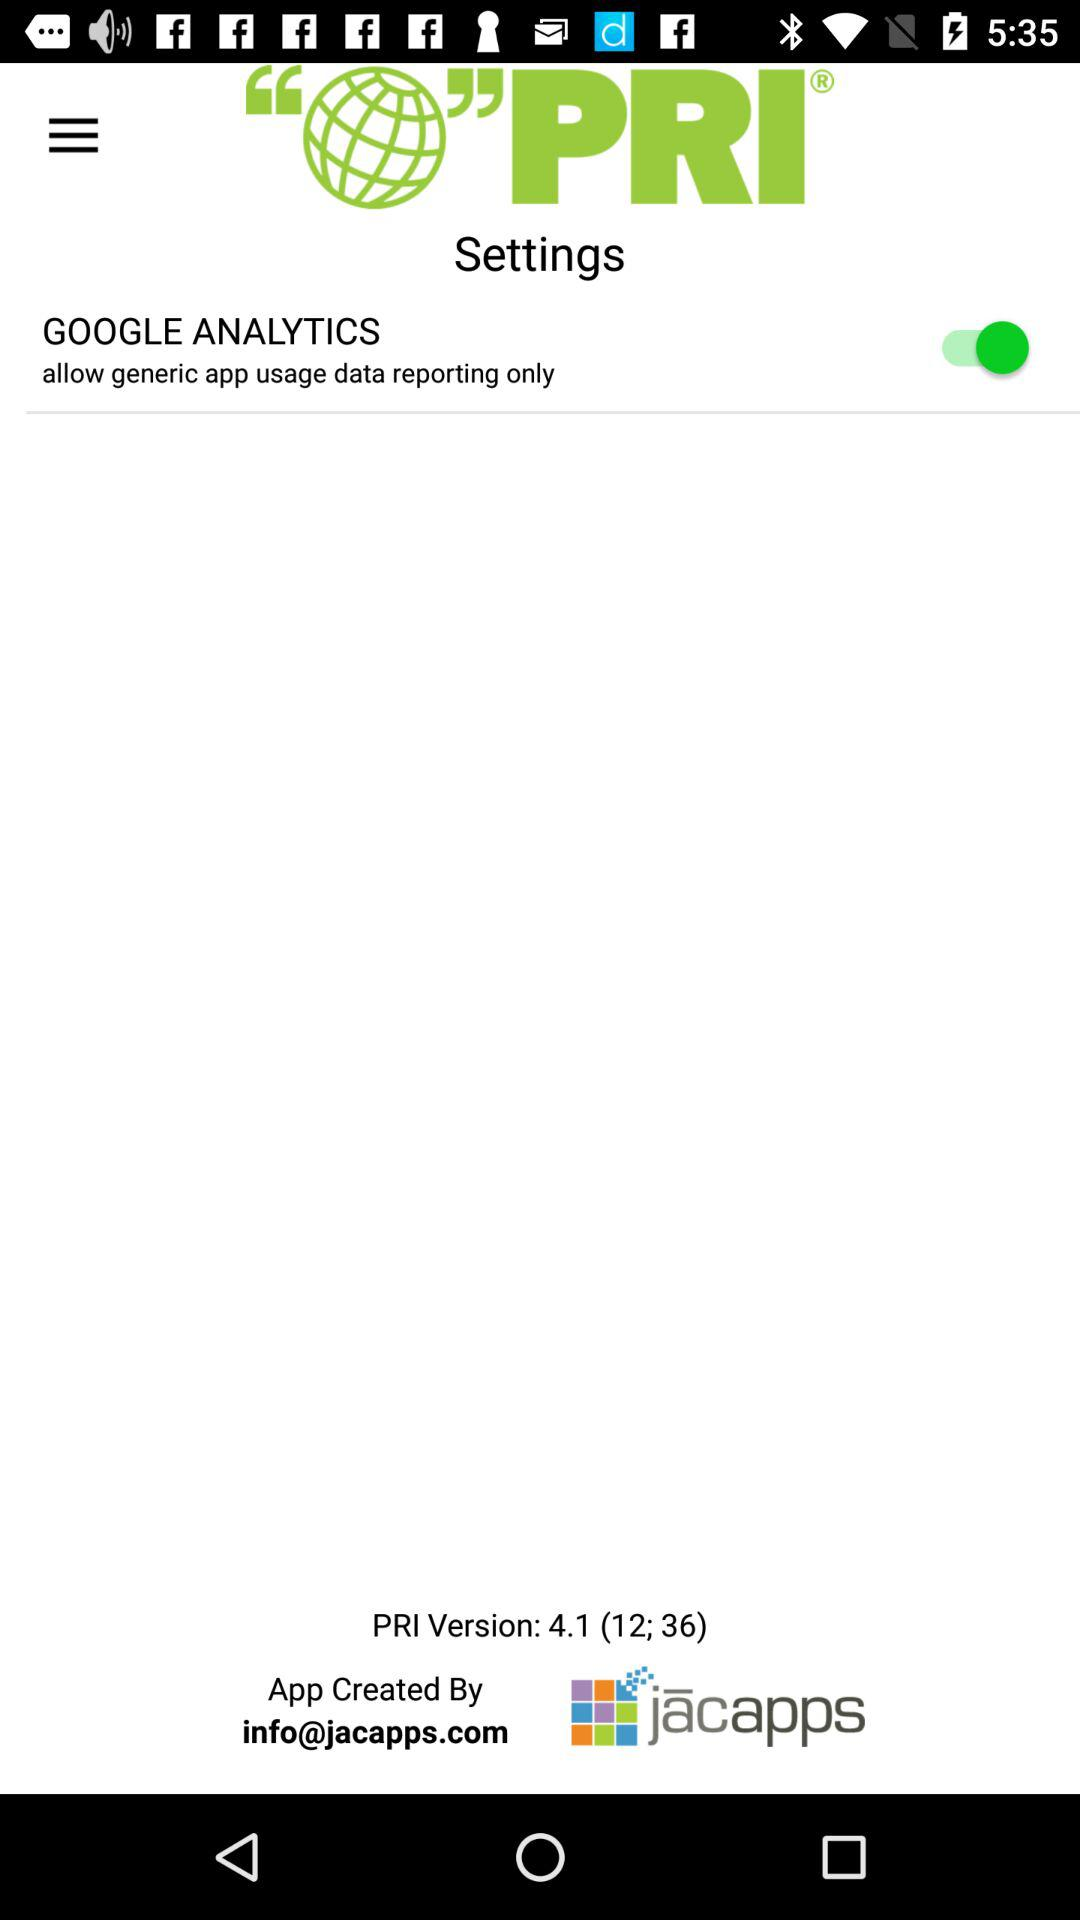What is the application name? The application name is "PRI". 